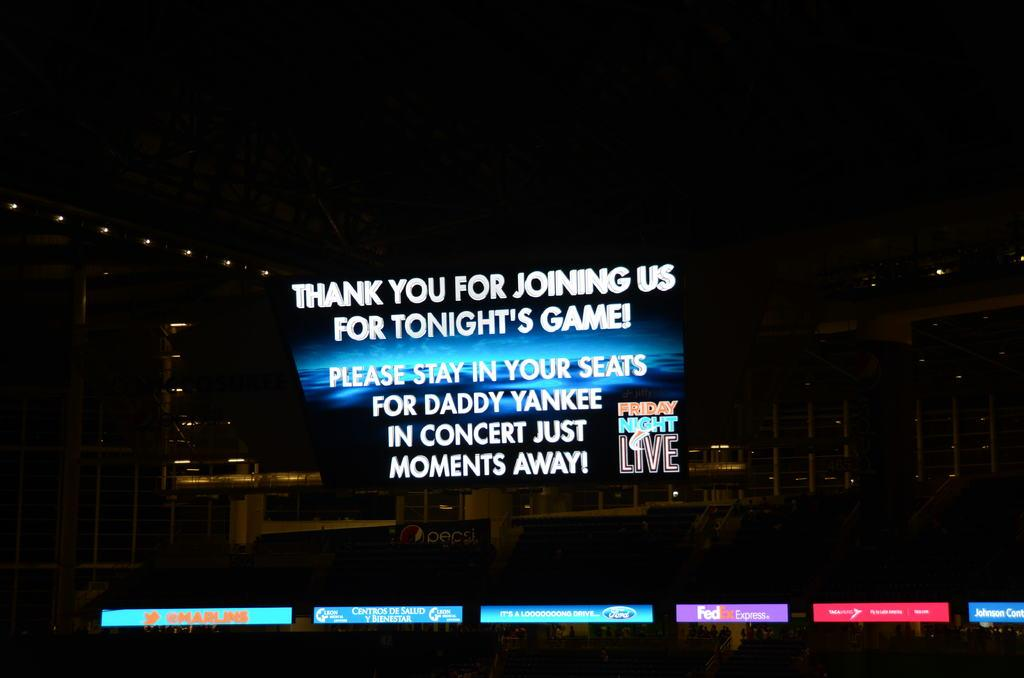<image>
Create a compact narrative representing the image presented. A television screen has Friday Night Live on the monitor with advertisements under it. 